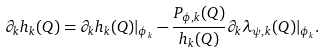<formula> <loc_0><loc_0><loc_500><loc_500>\partial _ { k } h _ { k } ( Q ) = \partial _ { k } h _ { k } ( Q ) | _ { \phi _ { k } } - \frac { P _ { \phi , k } ( Q ) } { h _ { k } ( Q ) } \partial _ { k } \lambda _ { \psi , k } ( Q ) | _ { \phi _ { k } } .</formula> 